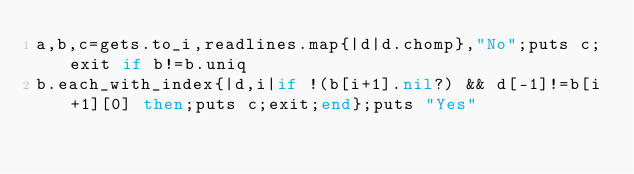<code> <loc_0><loc_0><loc_500><loc_500><_Ruby_>a,b,c=gets.to_i,readlines.map{|d|d.chomp},"No";puts c;exit if b!=b.uniq
b.each_with_index{|d,i|if !(b[i+1].nil?) && d[-1]!=b[i+1][0] then;puts c;exit;end};puts "Yes"</code> 